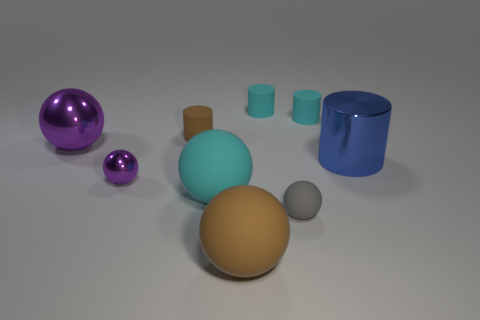Subtract all large blue shiny cylinders. How many cylinders are left? 3 Subtract all brown blocks. How many cyan cylinders are left? 2 Subtract all blue cylinders. How many cylinders are left? 3 Subtract 2 balls. How many balls are left? 3 Subtract all cylinders. How many objects are left? 5 Subtract all cyan cylinders. Subtract all cyan cylinders. How many objects are left? 5 Add 2 big cyan things. How many big cyan things are left? 3 Add 6 large green balls. How many large green balls exist? 6 Subtract 0 yellow cylinders. How many objects are left? 9 Subtract all red cylinders. Subtract all cyan spheres. How many cylinders are left? 4 